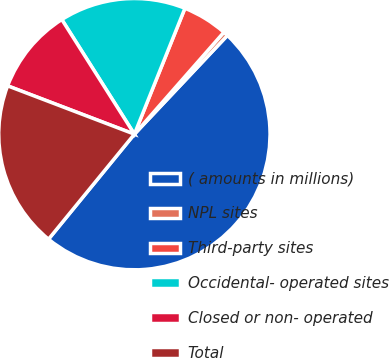Convert chart to OTSL. <chart><loc_0><loc_0><loc_500><loc_500><pie_chart><fcel>( amounts in millions)<fcel>NPL sites<fcel>Third-party sites<fcel>Occidental- operated sites<fcel>Closed or non- operated<fcel>Total<nl><fcel>48.88%<fcel>0.56%<fcel>5.39%<fcel>15.06%<fcel>10.22%<fcel>19.89%<nl></chart> 